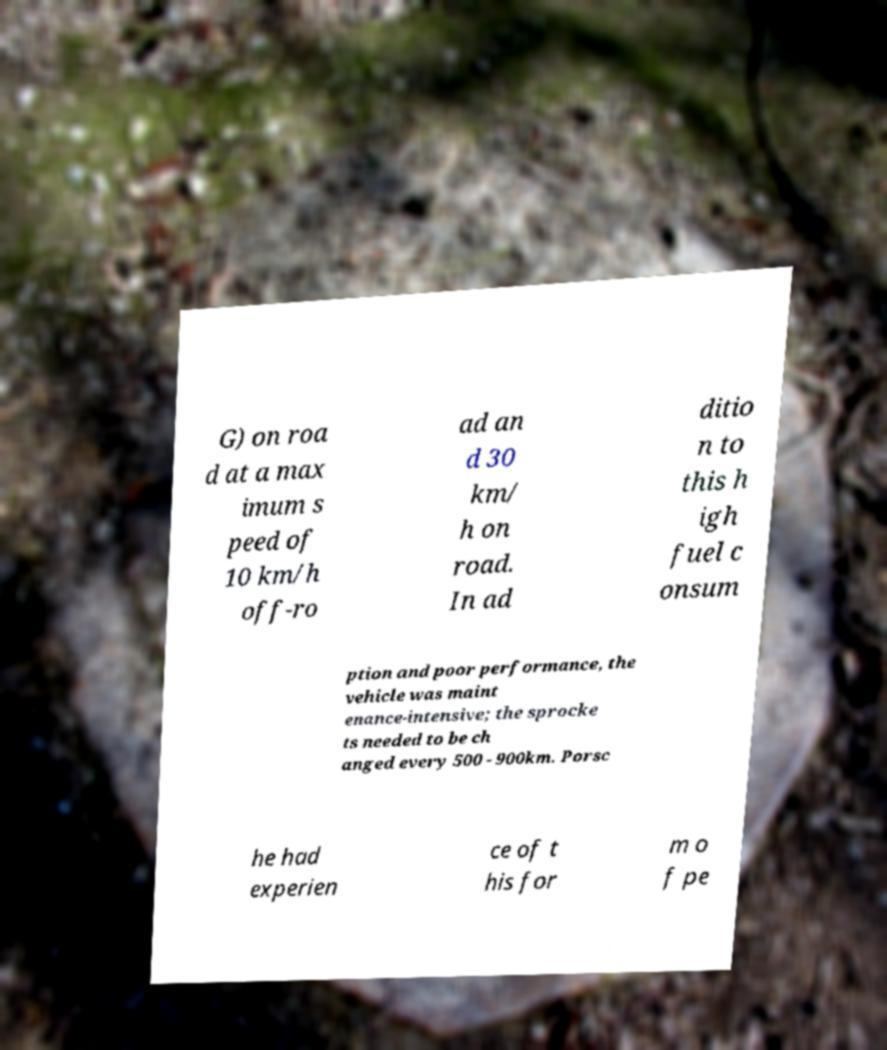Can you accurately transcribe the text from the provided image for me? G) on roa d at a max imum s peed of 10 km/h off-ro ad an d 30 km/ h on road. In ad ditio n to this h igh fuel c onsum ption and poor performance, the vehicle was maint enance-intensive; the sprocke ts needed to be ch anged every 500 - 900km. Porsc he had experien ce of t his for m o f pe 